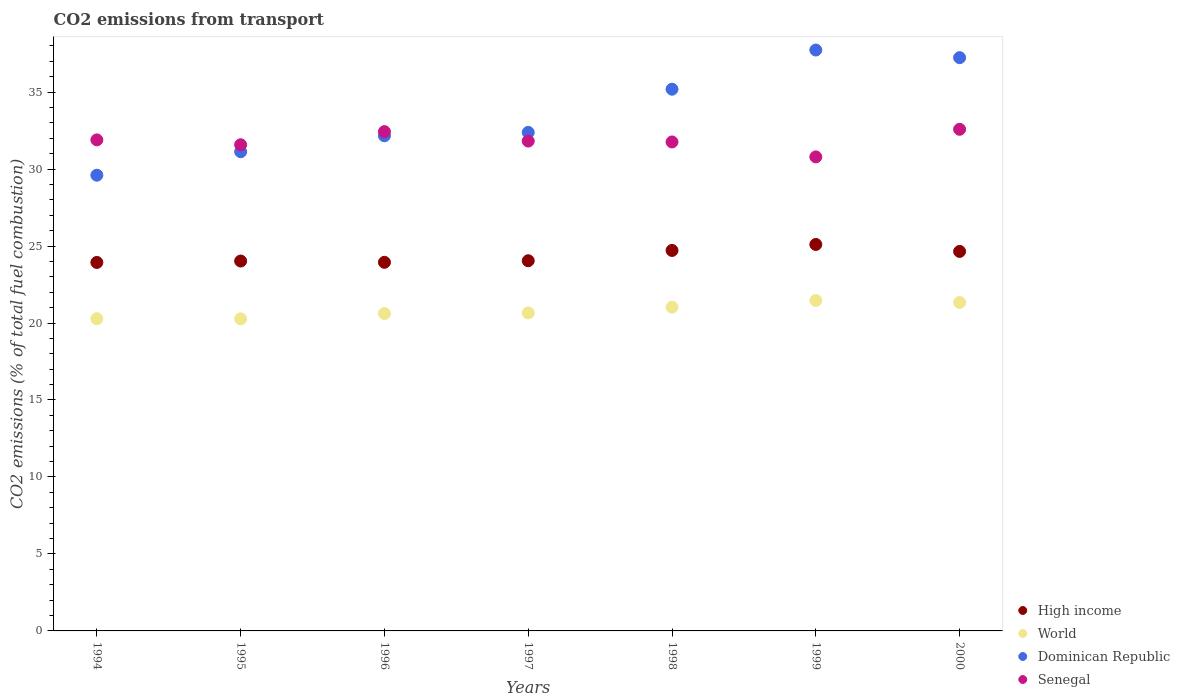How many different coloured dotlines are there?
Keep it short and to the point. 4. What is the total CO2 emitted in Senegal in 1995?
Your response must be concise. 31.58. Across all years, what is the maximum total CO2 emitted in Senegal?
Make the answer very short. 32.58. Across all years, what is the minimum total CO2 emitted in World?
Offer a very short reply. 20.27. In which year was the total CO2 emitted in High income maximum?
Ensure brevity in your answer.  1999. What is the total total CO2 emitted in High income in the graph?
Offer a very short reply. 170.42. What is the difference between the total CO2 emitted in World in 1997 and that in 1998?
Your answer should be very brief. -0.37. What is the difference between the total CO2 emitted in World in 1999 and the total CO2 emitted in High income in 2000?
Ensure brevity in your answer.  -3.19. What is the average total CO2 emitted in Dominican Republic per year?
Provide a succinct answer. 33.63. In the year 1998, what is the difference between the total CO2 emitted in Senegal and total CO2 emitted in World?
Your answer should be compact. 10.73. In how many years, is the total CO2 emitted in World greater than 17?
Offer a terse response. 7. What is the ratio of the total CO2 emitted in Dominican Republic in 1995 to that in 2000?
Your response must be concise. 0.84. Is the total CO2 emitted in Dominican Republic in 1994 less than that in 1995?
Your answer should be very brief. Yes. Is the difference between the total CO2 emitted in Senegal in 1995 and 1998 greater than the difference between the total CO2 emitted in World in 1995 and 1998?
Provide a succinct answer. Yes. What is the difference between the highest and the second highest total CO2 emitted in Dominican Republic?
Your answer should be very brief. 0.5. What is the difference between the highest and the lowest total CO2 emitted in World?
Provide a succinct answer. 1.19. In how many years, is the total CO2 emitted in High income greater than the average total CO2 emitted in High income taken over all years?
Ensure brevity in your answer.  3. Is the sum of the total CO2 emitted in Dominican Republic in 1996 and 1999 greater than the maximum total CO2 emitted in Senegal across all years?
Offer a terse response. Yes. Is it the case that in every year, the sum of the total CO2 emitted in Senegal and total CO2 emitted in High income  is greater than the sum of total CO2 emitted in World and total CO2 emitted in Dominican Republic?
Give a very brief answer. Yes. Does the total CO2 emitted in World monotonically increase over the years?
Give a very brief answer. No. Is the total CO2 emitted in High income strictly less than the total CO2 emitted in World over the years?
Offer a very short reply. No. How many dotlines are there?
Your answer should be compact. 4. How many years are there in the graph?
Your response must be concise. 7. Are the values on the major ticks of Y-axis written in scientific E-notation?
Offer a terse response. No. Does the graph contain any zero values?
Offer a terse response. No. Does the graph contain grids?
Your answer should be compact. No. What is the title of the graph?
Provide a short and direct response. CO2 emissions from transport. What is the label or title of the Y-axis?
Give a very brief answer. CO2 emissions (% of total fuel combustion). What is the CO2 emissions (% of total fuel combustion) of High income in 1994?
Give a very brief answer. 23.93. What is the CO2 emissions (% of total fuel combustion) of World in 1994?
Your answer should be very brief. 20.28. What is the CO2 emissions (% of total fuel combustion) of Dominican Republic in 1994?
Offer a very short reply. 29.6. What is the CO2 emissions (% of total fuel combustion) in Senegal in 1994?
Provide a short and direct response. 31.9. What is the CO2 emissions (% of total fuel combustion) of High income in 1995?
Ensure brevity in your answer.  24.03. What is the CO2 emissions (% of total fuel combustion) of World in 1995?
Keep it short and to the point. 20.27. What is the CO2 emissions (% of total fuel combustion) in Dominican Republic in 1995?
Your response must be concise. 31.13. What is the CO2 emissions (% of total fuel combustion) of Senegal in 1995?
Give a very brief answer. 31.58. What is the CO2 emissions (% of total fuel combustion) in High income in 1996?
Keep it short and to the point. 23.94. What is the CO2 emissions (% of total fuel combustion) of World in 1996?
Your answer should be very brief. 20.61. What is the CO2 emissions (% of total fuel combustion) of Dominican Republic in 1996?
Ensure brevity in your answer.  32.16. What is the CO2 emissions (% of total fuel combustion) of Senegal in 1996?
Your answer should be compact. 32.43. What is the CO2 emissions (% of total fuel combustion) in High income in 1997?
Provide a succinct answer. 24.05. What is the CO2 emissions (% of total fuel combustion) of World in 1997?
Give a very brief answer. 20.66. What is the CO2 emissions (% of total fuel combustion) in Dominican Republic in 1997?
Ensure brevity in your answer.  32.38. What is the CO2 emissions (% of total fuel combustion) in Senegal in 1997?
Give a very brief answer. 31.82. What is the CO2 emissions (% of total fuel combustion) in High income in 1998?
Provide a short and direct response. 24.71. What is the CO2 emissions (% of total fuel combustion) in World in 1998?
Keep it short and to the point. 21.03. What is the CO2 emissions (% of total fuel combustion) of Dominican Republic in 1998?
Keep it short and to the point. 35.19. What is the CO2 emissions (% of total fuel combustion) of Senegal in 1998?
Ensure brevity in your answer.  31.76. What is the CO2 emissions (% of total fuel combustion) of High income in 1999?
Keep it short and to the point. 25.1. What is the CO2 emissions (% of total fuel combustion) in World in 1999?
Ensure brevity in your answer.  21.46. What is the CO2 emissions (% of total fuel combustion) in Dominican Republic in 1999?
Give a very brief answer. 37.73. What is the CO2 emissions (% of total fuel combustion) of Senegal in 1999?
Ensure brevity in your answer.  30.79. What is the CO2 emissions (% of total fuel combustion) of High income in 2000?
Offer a terse response. 24.65. What is the CO2 emissions (% of total fuel combustion) in World in 2000?
Offer a terse response. 21.34. What is the CO2 emissions (% of total fuel combustion) in Dominican Republic in 2000?
Keep it short and to the point. 37.24. What is the CO2 emissions (% of total fuel combustion) of Senegal in 2000?
Your answer should be very brief. 32.58. Across all years, what is the maximum CO2 emissions (% of total fuel combustion) of High income?
Keep it short and to the point. 25.1. Across all years, what is the maximum CO2 emissions (% of total fuel combustion) of World?
Your response must be concise. 21.46. Across all years, what is the maximum CO2 emissions (% of total fuel combustion) in Dominican Republic?
Your response must be concise. 37.73. Across all years, what is the maximum CO2 emissions (% of total fuel combustion) of Senegal?
Ensure brevity in your answer.  32.58. Across all years, what is the minimum CO2 emissions (% of total fuel combustion) in High income?
Offer a terse response. 23.93. Across all years, what is the minimum CO2 emissions (% of total fuel combustion) of World?
Your answer should be compact. 20.27. Across all years, what is the minimum CO2 emissions (% of total fuel combustion) in Dominican Republic?
Keep it short and to the point. 29.6. Across all years, what is the minimum CO2 emissions (% of total fuel combustion) in Senegal?
Give a very brief answer. 30.79. What is the total CO2 emissions (% of total fuel combustion) in High income in the graph?
Provide a succinct answer. 170.42. What is the total CO2 emissions (% of total fuel combustion) in World in the graph?
Your answer should be very brief. 145.65. What is the total CO2 emissions (% of total fuel combustion) of Dominican Republic in the graph?
Provide a short and direct response. 235.43. What is the total CO2 emissions (% of total fuel combustion) in Senegal in the graph?
Provide a succinct answer. 222.86. What is the difference between the CO2 emissions (% of total fuel combustion) in High income in 1994 and that in 1995?
Your response must be concise. -0.09. What is the difference between the CO2 emissions (% of total fuel combustion) in World in 1994 and that in 1995?
Your response must be concise. 0.01. What is the difference between the CO2 emissions (% of total fuel combustion) of Dominican Republic in 1994 and that in 1995?
Offer a terse response. -1.53. What is the difference between the CO2 emissions (% of total fuel combustion) in Senegal in 1994 and that in 1995?
Your answer should be very brief. 0.32. What is the difference between the CO2 emissions (% of total fuel combustion) in High income in 1994 and that in 1996?
Give a very brief answer. -0.01. What is the difference between the CO2 emissions (% of total fuel combustion) in World in 1994 and that in 1996?
Your response must be concise. -0.34. What is the difference between the CO2 emissions (% of total fuel combustion) of Dominican Republic in 1994 and that in 1996?
Make the answer very short. -2.56. What is the difference between the CO2 emissions (% of total fuel combustion) in Senegal in 1994 and that in 1996?
Your answer should be compact. -0.54. What is the difference between the CO2 emissions (% of total fuel combustion) in High income in 1994 and that in 1997?
Your answer should be very brief. -0.11. What is the difference between the CO2 emissions (% of total fuel combustion) in World in 1994 and that in 1997?
Your answer should be compact. -0.38. What is the difference between the CO2 emissions (% of total fuel combustion) of Dominican Republic in 1994 and that in 1997?
Keep it short and to the point. -2.78. What is the difference between the CO2 emissions (% of total fuel combustion) in Senegal in 1994 and that in 1997?
Provide a short and direct response. 0.08. What is the difference between the CO2 emissions (% of total fuel combustion) of High income in 1994 and that in 1998?
Keep it short and to the point. -0.78. What is the difference between the CO2 emissions (% of total fuel combustion) of World in 1994 and that in 1998?
Give a very brief answer. -0.75. What is the difference between the CO2 emissions (% of total fuel combustion) of Dominican Republic in 1994 and that in 1998?
Make the answer very short. -5.59. What is the difference between the CO2 emissions (% of total fuel combustion) of Senegal in 1994 and that in 1998?
Offer a terse response. 0.14. What is the difference between the CO2 emissions (% of total fuel combustion) in High income in 1994 and that in 1999?
Provide a short and direct response. -1.17. What is the difference between the CO2 emissions (% of total fuel combustion) in World in 1994 and that in 1999?
Your response must be concise. -1.18. What is the difference between the CO2 emissions (% of total fuel combustion) in Dominican Republic in 1994 and that in 1999?
Your response must be concise. -8.13. What is the difference between the CO2 emissions (% of total fuel combustion) in Senegal in 1994 and that in 1999?
Your answer should be very brief. 1.11. What is the difference between the CO2 emissions (% of total fuel combustion) of High income in 1994 and that in 2000?
Provide a succinct answer. -0.72. What is the difference between the CO2 emissions (% of total fuel combustion) of World in 1994 and that in 2000?
Provide a succinct answer. -1.06. What is the difference between the CO2 emissions (% of total fuel combustion) in Dominican Republic in 1994 and that in 2000?
Your answer should be very brief. -7.64. What is the difference between the CO2 emissions (% of total fuel combustion) in Senegal in 1994 and that in 2000?
Your answer should be very brief. -0.69. What is the difference between the CO2 emissions (% of total fuel combustion) in High income in 1995 and that in 1996?
Your response must be concise. 0.08. What is the difference between the CO2 emissions (% of total fuel combustion) in World in 1995 and that in 1996?
Your answer should be compact. -0.34. What is the difference between the CO2 emissions (% of total fuel combustion) of Dominican Republic in 1995 and that in 1996?
Give a very brief answer. -1.04. What is the difference between the CO2 emissions (% of total fuel combustion) in Senegal in 1995 and that in 1996?
Provide a short and direct response. -0.85. What is the difference between the CO2 emissions (% of total fuel combustion) of High income in 1995 and that in 1997?
Your response must be concise. -0.02. What is the difference between the CO2 emissions (% of total fuel combustion) of World in 1995 and that in 1997?
Your answer should be compact. -0.39. What is the difference between the CO2 emissions (% of total fuel combustion) in Dominican Republic in 1995 and that in 1997?
Provide a succinct answer. -1.25. What is the difference between the CO2 emissions (% of total fuel combustion) in Senegal in 1995 and that in 1997?
Offer a very short reply. -0.24. What is the difference between the CO2 emissions (% of total fuel combustion) in High income in 1995 and that in 1998?
Make the answer very short. -0.69. What is the difference between the CO2 emissions (% of total fuel combustion) of World in 1995 and that in 1998?
Give a very brief answer. -0.76. What is the difference between the CO2 emissions (% of total fuel combustion) of Dominican Republic in 1995 and that in 1998?
Make the answer very short. -4.06. What is the difference between the CO2 emissions (% of total fuel combustion) in Senegal in 1995 and that in 1998?
Offer a very short reply. -0.18. What is the difference between the CO2 emissions (% of total fuel combustion) in High income in 1995 and that in 1999?
Give a very brief answer. -1.08. What is the difference between the CO2 emissions (% of total fuel combustion) of World in 1995 and that in 1999?
Your response must be concise. -1.19. What is the difference between the CO2 emissions (% of total fuel combustion) in Dominican Republic in 1995 and that in 1999?
Ensure brevity in your answer.  -6.61. What is the difference between the CO2 emissions (% of total fuel combustion) of Senegal in 1995 and that in 1999?
Keep it short and to the point. 0.79. What is the difference between the CO2 emissions (% of total fuel combustion) in High income in 1995 and that in 2000?
Ensure brevity in your answer.  -0.62. What is the difference between the CO2 emissions (% of total fuel combustion) of World in 1995 and that in 2000?
Keep it short and to the point. -1.07. What is the difference between the CO2 emissions (% of total fuel combustion) in Dominican Republic in 1995 and that in 2000?
Keep it short and to the point. -6.11. What is the difference between the CO2 emissions (% of total fuel combustion) of Senegal in 1995 and that in 2000?
Keep it short and to the point. -1.01. What is the difference between the CO2 emissions (% of total fuel combustion) of High income in 1996 and that in 1997?
Ensure brevity in your answer.  -0.1. What is the difference between the CO2 emissions (% of total fuel combustion) in World in 1996 and that in 1997?
Give a very brief answer. -0.04. What is the difference between the CO2 emissions (% of total fuel combustion) of Dominican Republic in 1996 and that in 1997?
Provide a succinct answer. -0.22. What is the difference between the CO2 emissions (% of total fuel combustion) in Senegal in 1996 and that in 1997?
Provide a short and direct response. 0.61. What is the difference between the CO2 emissions (% of total fuel combustion) of High income in 1996 and that in 1998?
Provide a short and direct response. -0.77. What is the difference between the CO2 emissions (% of total fuel combustion) in World in 1996 and that in 1998?
Make the answer very short. -0.41. What is the difference between the CO2 emissions (% of total fuel combustion) of Dominican Republic in 1996 and that in 1998?
Make the answer very short. -3.02. What is the difference between the CO2 emissions (% of total fuel combustion) of Senegal in 1996 and that in 1998?
Keep it short and to the point. 0.67. What is the difference between the CO2 emissions (% of total fuel combustion) of High income in 1996 and that in 1999?
Offer a terse response. -1.16. What is the difference between the CO2 emissions (% of total fuel combustion) in World in 1996 and that in 1999?
Give a very brief answer. -0.85. What is the difference between the CO2 emissions (% of total fuel combustion) of Dominican Republic in 1996 and that in 1999?
Give a very brief answer. -5.57. What is the difference between the CO2 emissions (% of total fuel combustion) of Senegal in 1996 and that in 1999?
Give a very brief answer. 1.64. What is the difference between the CO2 emissions (% of total fuel combustion) of High income in 1996 and that in 2000?
Offer a very short reply. -0.71. What is the difference between the CO2 emissions (% of total fuel combustion) in World in 1996 and that in 2000?
Ensure brevity in your answer.  -0.72. What is the difference between the CO2 emissions (% of total fuel combustion) of Dominican Republic in 1996 and that in 2000?
Make the answer very short. -5.07. What is the difference between the CO2 emissions (% of total fuel combustion) in Senegal in 1996 and that in 2000?
Give a very brief answer. -0.15. What is the difference between the CO2 emissions (% of total fuel combustion) of High income in 1997 and that in 1998?
Your answer should be very brief. -0.67. What is the difference between the CO2 emissions (% of total fuel combustion) of World in 1997 and that in 1998?
Give a very brief answer. -0.37. What is the difference between the CO2 emissions (% of total fuel combustion) of Dominican Republic in 1997 and that in 1998?
Make the answer very short. -2.81. What is the difference between the CO2 emissions (% of total fuel combustion) of Senegal in 1997 and that in 1998?
Give a very brief answer. 0.06. What is the difference between the CO2 emissions (% of total fuel combustion) in High income in 1997 and that in 1999?
Your answer should be very brief. -1.06. What is the difference between the CO2 emissions (% of total fuel combustion) of World in 1997 and that in 1999?
Give a very brief answer. -0.81. What is the difference between the CO2 emissions (% of total fuel combustion) of Dominican Republic in 1997 and that in 1999?
Your response must be concise. -5.35. What is the difference between the CO2 emissions (% of total fuel combustion) in Senegal in 1997 and that in 1999?
Make the answer very short. 1.03. What is the difference between the CO2 emissions (% of total fuel combustion) of High income in 1997 and that in 2000?
Keep it short and to the point. -0.6. What is the difference between the CO2 emissions (% of total fuel combustion) in World in 1997 and that in 2000?
Ensure brevity in your answer.  -0.68. What is the difference between the CO2 emissions (% of total fuel combustion) in Dominican Republic in 1997 and that in 2000?
Your answer should be very brief. -4.86. What is the difference between the CO2 emissions (% of total fuel combustion) in Senegal in 1997 and that in 2000?
Ensure brevity in your answer.  -0.77. What is the difference between the CO2 emissions (% of total fuel combustion) in High income in 1998 and that in 1999?
Make the answer very short. -0.39. What is the difference between the CO2 emissions (% of total fuel combustion) in World in 1998 and that in 1999?
Your answer should be very brief. -0.43. What is the difference between the CO2 emissions (% of total fuel combustion) of Dominican Republic in 1998 and that in 1999?
Your answer should be compact. -2.55. What is the difference between the CO2 emissions (% of total fuel combustion) in High income in 1998 and that in 2000?
Your response must be concise. 0.06. What is the difference between the CO2 emissions (% of total fuel combustion) of World in 1998 and that in 2000?
Keep it short and to the point. -0.31. What is the difference between the CO2 emissions (% of total fuel combustion) of Dominican Republic in 1998 and that in 2000?
Give a very brief answer. -2.05. What is the difference between the CO2 emissions (% of total fuel combustion) in Senegal in 1998 and that in 2000?
Provide a short and direct response. -0.82. What is the difference between the CO2 emissions (% of total fuel combustion) of High income in 1999 and that in 2000?
Your response must be concise. 0.45. What is the difference between the CO2 emissions (% of total fuel combustion) of World in 1999 and that in 2000?
Keep it short and to the point. 0.13. What is the difference between the CO2 emissions (% of total fuel combustion) of Dominican Republic in 1999 and that in 2000?
Offer a terse response. 0.5. What is the difference between the CO2 emissions (% of total fuel combustion) of Senegal in 1999 and that in 2000?
Offer a terse response. -1.79. What is the difference between the CO2 emissions (% of total fuel combustion) of High income in 1994 and the CO2 emissions (% of total fuel combustion) of World in 1995?
Provide a short and direct response. 3.66. What is the difference between the CO2 emissions (% of total fuel combustion) in High income in 1994 and the CO2 emissions (% of total fuel combustion) in Dominican Republic in 1995?
Your answer should be very brief. -7.19. What is the difference between the CO2 emissions (% of total fuel combustion) of High income in 1994 and the CO2 emissions (% of total fuel combustion) of Senegal in 1995?
Provide a succinct answer. -7.64. What is the difference between the CO2 emissions (% of total fuel combustion) of World in 1994 and the CO2 emissions (% of total fuel combustion) of Dominican Republic in 1995?
Your answer should be very brief. -10.85. What is the difference between the CO2 emissions (% of total fuel combustion) of World in 1994 and the CO2 emissions (% of total fuel combustion) of Senegal in 1995?
Your answer should be compact. -11.3. What is the difference between the CO2 emissions (% of total fuel combustion) in Dominican Republic in 1994 and the CO2 emissions (% of total fuel combustion) in Senegal in 1995?
Offer a terse response. -1.98. What is the difference between the CO2 emissions (% of total fuel combustion) in High income in 1994 and the CO2 emissions (% of total fuel combustion) in World in 1996?
Ensure brevity in your answer.  3.32. What is the difference between the CO2 emissions (% of total fuel combustion) in High income in 1994 and the CO2 emissions (% of total fuel combustion) in Dominican Republic in 1996?
Give a very brief answer. -8.23. What is the difference between the CO2 emissions (% of total fuel combustion) in High income in 1994 and the CO2 emissions (% of total fuel combustion) in Senegal in 1996?
Provide a succinct answer. -8.5. What is the difference between the CO2 emissions (% of total fuel combustion) in World in 1994 and the CO2 emissions (% of total fuel combustion) in Dominican Republic in 1996?
Ensure brevity in your answer.  -11.89. What is the difference between the CO2 emissions (% of total fuel combustion) of World in 1994 and the CO2 emissions (% of total fuel combustion) of Senegal in 1996?
Your answer should be compact. -12.15. What is the difference between the CO2 emissions (% of total fuel combustion) of Dominican Republic in 1994 and the CO2 emissions (% of total fuel combustion) of Senegal in 1996?
Offer a very short reply. -2.83. What is the difference between the CO2 emissions (% of total fuel combustion) in High income in 1994 and the CO2 emissions (% of total fuel combustion) in World in 1997?
Your response must be concise. 3.28. What is the difference between the CO2 emissions (% of total fuel combustion) in High income in 1994 and the CO2 emissions (% of total fuel combustion) in Dominican Republic in 1997?
Provide a succinct answer. -8.45. What is the difference between the CO2 emissions (% of total fuel combustion) of High income in 1994 and the CO2 emissions (% of total fuel combustion) of Senegal in 1997?
Keep it short and to the point. -7.88. What is the difference between the CO2 emissions (% of total fuel combustion) in World in 1994 and the CO2 emissions (% of total fuel combustion) in Dominican Republic in 1997?
Offer a very short reply. -12.1. What is the difference between the CO2 emissions (% of total fuel combustion) of World in 1994 and the CO2 emissions (% of total fuel combustion) of Senegal in 1997?
Your answer should be compact. -11.54. What is the difference between the CO2 emissions (% of total fuel combustion) in Dominican Republic in 1994 and the CO2 emissions (% of total fuel combustion) in Senegal in 1997?
Ensure brevity in your answer.  -2.22. What is the difference between the CO2 emissions (% of total fuel combustion) of High income in 1994 and the CO2 emissions (% of total fuel combustion) of World in 1998?
Make the answer very short. 2.91. What is the difference between the CO2 emissions (% of total fuel combustion) in High income in 1994 and the CO2 emissions (% of total fuel combustion) in Dominican Republic in 1998?
Your answer should be very brief. -11.25. What is the difference between the CO2 emissions (% of total fuel combustion) of High income in 1994 and the CO2 emissions (% of total fuel combustion) of Senegal in 1998?
Your answer should be very brief. -7.83. What is the difference between the CO2 emissions (% of total fuel combustion) in World in 1994 and the CO2 emissions (% of total fuel combustion) in Dominican Republic in 1998?
Your answer should be compact. -14.91. What is the difference between the CO2 emissions (% of total fuel combustion) of World in 1994 and the CO2 emissions (% of total fuel combustion) of Senegal in 1998?
Offer a very short reply. -11.48. What is the difference between the CO2 emissions (% of total fuel combustion) in Dominican Republic in 1994 and the CO2 emissions (% of total fuel combustion) in Senegal in 1998?
Give a very brief answer. -2.16. What is the difference between the CO2 emissions (% of total fuel combustion) of High income in 1994 and the CO2 emissions (% of total fuel combustion) of World in 1999?
Your answer should be compact. 2.47. What is the difference between the CO2 emissions (% of total fuel combustion) of High income in 1994 and the CO2 emissions (% of total fuel combustion) of Dominican Republic in 1999?
Provide a succinct answer. -13.8. What is the difference between the CO2 emissions (% of total fuel combustion) in High income in 1994 and the CO2 emissions (% of total fuel combustion) in Senegal in 1999?
Give a very brief answer. -6.86. What is the difference between the CO2 emissions (% of total fuel combustion) in World in 1994 and the CO2 emissions (% of total fuel combustion) in Dominican Republic in 1999?
Provide a succinct answer. -17.45. What is the difference between the CO2 emissions (% of total fuel combustion) of World in 1994 and the CO2 emissions (% of total fuel combustion) of Senegal in 1999?
Ensure brevity in your answer.  -10.51. What is the difference between the CO2 emissions (% of total fuel combustion) in Dominican Republic in 1994 and the CO2 emissions (% of total fuel combustion) in Senegal in 1999?
Provide a succinct answer. -1.19. What is the difference between the CO2 emissions (% of total fuel combustion) of High income in 1994 and the CO2 emissions (% of total fuel combustion) of World in 2000?
Give a very brief answer. 2.6. What is the difference between the CO2 emissions (% of total fuel combustion) in High income in 1994 and the CO2 emissions (% of total fuel combustion) in Dominican Republic in 2000?
Provide a succinct answer. -13.3. What is the difference between the CO2 emissions (% of total fuel combustion) of High income in 1994 and the CO2 emissions (% of total fuel combustion) of Senegal in 2000?
Your answer should be compact. -8.65. What is the difference between the CO2 emissions (% of total fuel combustion) of World in 1994 and the CO2 emissions (% of total fuel combustion) of Dominican Republic in 2000?
Provide a succinct answer. -16.96. What is the difference between the CO2 emissions (% of total fuel combustion) in World in 1994 and the CO2 emissions (% of total fuel combustion) in Senegal in 2000?
Your answer should be very brief. -12.31. What is the difference between the CO2 emissions (% of total fuel combustion) in Dominican Republic in 1994 and the CO2 emissions (% of total fuel combustion) in Senegal in 2000?
Keep it short and to the point. -2.98. What is the difference between the CO2 emissions (% of total fuel combustion) in High income in 1995 and the CO2 emissions (% of total fuel combustion) in World in 1996?
Give a very brief answer. 3.41. What is the difference between the CO2 emissions (% of total fuel combustion) of High income in 1995 and the CO2 emissions (% of total fuel combustion) of Dominican Republic in 1996?
Your answer should be compact. -8.14. What is the difference between the CO2 emissions (% of total fuel combustion) in High income in 1995 and the CO2 emissions (% of total fuel combustion) in Senegal in 1996?
Offer a terse response. -8.41. What is the difference between the CO2 emissions (% of total fuel combustion) in World in 1995 and the CO2 emissions (% of total fuel combustion) in Dominican Republic in 1996?
Your response must be concise. -11.89. What is the difference between the CO2 emissions (% of total fuel combustion) in World in 1995 and the CO2 emissions (% of total fuel combustion) in Senegal in 1996?
Make the answer very short. -12.16. What is the difference between the CO2 emissions (% of total fuel combustion) of Dominican Republic in 1995 and the CO2 emissions (% of total fuel combustion) of Senegal in 1996?
Offer a terse response. -1.31. What is the difference between the CO2 emissions (% of total fuel combustion) of High income in 1995 and the CO2 emissions (% of total fuel combustion) of World in 1997?
Your answer should be very brief. 3.37. What is the difference between the CO2 emissions (% of total fuel combustion) in High income in 1995 and the CO2 emissions (% of total fuel combustion) in Dominican Republic in 1997?
Provide a succinct answer. -8.35. What is the difference between the CO2 emissions (% of total fuel combustion) in High income in 1995 and the CO2 emissions (% of total fuel combustion) in Senegal in 1997?
Your response must be concise. -7.79. What is the difference between the CO2 emissions (% of total fuel combustion) in World in 1995 and the CO2 emissions (% of total fuel combustion) in Dominican Republic in 1997?
Keep it short and to the point. -12.11. What is the difference between the CO2 emissions (% of total fuel combustion) of World in 1995 and the CO2 emissions (% of total fuel combustion) of Senegal in 1997?
Provide a short and direct response. -11.55. What is the difference between the CO2 emissions (% of total fuel combustion) in Dominican Republic in 1995 and the CO2 emissions (% of total fuel combustion) in Senegal in 1997?
Offer a very short reply. -0.69. What is the difference between the CO2 emissions (% of total fuel combustion) in High income in 1995 and the CO2 emissions (% of total fuel combustion) in World in 1998?
Offer a very short reply. 3. What is the difference between the CO2 emissions (% of total fuel combustion) in High income in 1995 and the CO2 emissions (% of total fuel combustion) in Dominican Republic in 1998?
Your answer should be very brief. -11.16. What is the difference between the CO2 emissions (% of total fuel combustion) in High income in 1995 and the CO2 emissions (% of total fuel combustion) in Senegal in 1998?
Offer a very short reply. -7.73. What is the difference between the CO2 emissions (% of total fuel combustion) of World in 1995 and the CO2 emissions (% of total fuel combustion) of Dominican Republic in 1998?
Ensure brevity in your answer.  -14.92. What is the difference between the CO2 emissions (% of total fuel combustion) in World in 1995 and the CO2 emissions (% of total fuel combustion) in Senegal in 1998?
Make the answer very short. -11.49. What is the difference between the CO2 emissions (% of total fuel combustion) in Dominican Republic in 1995 and the CO2 emissions (% of total fuel combustion) in Senegal in 1998?
Make the answer very short. -0.63. What is the difference between the CO2 emissions (% of total fuel combustion) in High income in 1995 and the CO2 emissions (% of total fuel combustion) in World in 1999?
Make the answer very short. 2.56. What is the difference between the CO2 emissions (% of total fuel combustion) of High income in 1995 and the CO2 emissions (% of total fuel combustion) of Dominican Republic in 1999?
Your answer should be very brief. -13.71. What is the difference between the CO2 emissions (% of total fuel combustion) in High income in 1995 and the CO2 emissions (% of total fuel combustion) in Senegal in 1999?
Provide a succinct answer. -6.76. What is the difference between the CO2 emissions (% of total fuel combustion) in World in 1995 and the CO2 emissions (% of total fuel combustion) in Dominican Republic in 1999?
Give a very brief answer. -17.46. What is the difference between the CO2 emissions (% of total fuel combustion) in World in 1995 and the CO2 emissions (% of total fuel combustion) in Senegal in 1999?
Your answer should be very brief. -10.52. What is the difference between the CO2 emissions (% of total fuel combustion) of Dominican Republic in 1995 and the CO2 emissions (% of total fuel combustion) of Senegal in 1999?
Your answer should be very brief. 0.34. What is the difference between the CO2 emissions (% of total fuel combustion) in High income in 1995 and the CO2 emissions (% of total fuel combustion) in World in 2000?
Provide a short and direct response. 2.69. What is the difference between the CO2 emissions (% of total fuel combustion) of High income in 1995 and the CO2 emissions (% of total fuel combustion) of Dominican Republic in 2000?
Your response must be concise. -13.21. What is the difference between the CO2 emissions (% of total fuel combustion) in High income in 1995 and the CO2 emissions (% of total fuel combustion) in Senegal in 2000?
Provide a short and direct response. -8.56. What is the difference between the CO2 emissions (% of total fuel combustion) in World in 1995 and the CO2 emissions (% of total fuel combustion) in Dominican Republic in 2000?
Give a very brief answer. -16.96. What is the difference between the CO2 emissions (% of total fuel combustion) of World in 1995 and the CO2 emissions (% of total fuel combustion) of Senegal in 2000?
Provide a succinct answer. -12.31. What is the difference between the CO2 emissions (% of total fuel combustion) of Dominican Republic in 1995 and the CO2 emissions (% of total fuel combustion) of Senegal in 2000?
Your answer should be very brief. -1.46. What is the difference between the CO2 emissions (% of total fuel combustion) of High income in 1996 and the CO2 emissions (% of total fuel combustion) of World in 1997?
Offer a very short reply. 3.29. What is the difference between the CO2 emissions (% of total fuel combustion) in High income in 1996 and the CO2 emissions (% of total fuel combustion) in Dominican Republic in 1997?
Provide a succinct answer. -8.44. What is the difference between the CO2 emissions (% of total fuel combustion) in High income in 1996 and the CO2 emissions (% of total fuel combustion) in Senegal in 1997?
Your answer should be very brief. -7.88. What is the difference between the CO2 emissions (% of total fuel combustion) of World in 1996 and the CO2 emissions (% of total fuel combustion) of Dominican Republic in 1997?
Offer a terse response. -11.77. What is the difference between the CO2 emissions (% of total fuel combustion) in World in 1996 and the CO2 emissions (% of total fuel combustion) in Senegal in 1997?
Your response must be concise. -11.2. What is the difference between the CO2 emissions (% of total fuel combustion) in Dominican Republic in 1996 and the CO2 emissions (% of total fuel combustion) in Senegal in 1997?
Offer a very short reply. 0.35. What is the difference between the CO2 emissions (% of total fuel combustion) in High income in 1996 and the CO2 emissions (% of total fuel combustion) in World in 1998?
Make the answer very short. 2.92. What is the difference between the CO2 emissions (% of total fuel combustion) in High income in 1996 and the CO2 emissions (% of total fuel combustion) in Dominican Republic in 1998?
Ensure brevity in your answer.  -11.24. What is the difference between the CO2 emissions (% of total fuel combustion) of High income in 1996 and the CO2 emissions (% of total fuel combustion) of Senegal in 1998?
Provide a succinct answer. -7.82. What is the difference between the CO2 emissions (% of total fuel combustion) in World in 1996 and the CO2 emissions (% of total fuel combustion) in Dominican Republic in 1998?
Provide a short and direct response. -14.57. What is the difference between the CO2 emissions (% of total fuel combustion) in World in 1996 and the CO2 emissions (% of total fuel combustion) in Senegal in 1998?
Give a very brief answer. -11.15. What is the difference between the CO2 emissions (% of total fuel combustion) of Dominican Republic in 1996 and the CO2 emissions (% of total fuel combustion) of Senegal in 1998?
Ensure brevity in your answer.  0.4. What is the difference between the CO2 emissions (% of total fuel combustion) in High income in 1996 and the CO2 emissions (% of total fuel combustion) in World in 1999?
Give a very brief answer. 2.48. What is the difference between the CO2 emissions (% of total fuel combustion) in High income in 1996 and the CO2 emissions (% of total fuel combustion) in Dominican Republic in 1999?
Offer a very short reply. -13.79. What is the difference between the CO2 emissions (% of total fuel combustion) of High income in 1996 and the CO2 emissions (% of total fuel combustion) of Senegal in 1999?
Your response must be concise. -6.85. What is the difference between the CO2 emissions (% of total fuel combustion) of World in 1996 and the CO2 emissions (% of total fuel combustion) of Dominican Republic in 1999?
Provide a short and direct response. -17.12. What is the difference between the CO2 emissions (% of total fuel combustion) in World in 1996 and the CO2 emissions (% of total fuel combustion) in Senegal in 1999?
Make the answer very short. -10.18. What is the difference between the CO2 emissions (% of total fuel combustion) in Dominican Republic in 1996 and the CO2 emissions (% of total fuel combustion) in Senegal in 1999?
Give a very brief answer. 1.37. What is the difference between the CO2 emissions (% of total fuel combustion) of High income in 1996 and the CO2 emissions (% of total fuel combustion) of World in 2000?
Your answer should be very brief. 2.61. What is the difference between the CO2 emissions (% of total fuel combustion) in High income in 1996 and the CO2 emissions (% of total fuel combustion) in Dominican Republic in 2000?
Provide a succinct answer. -13.29. What is the difference between the CO2 emissions (% of total fuel combustion) in High income in 1996 and the CO2 emissions (% of total fuel combustion) in Senegal in 2000?
Ensure brevity in your answer.  -8.64. What is the difference between the CO2 emissions (% of total fuel combustion) in World in 1996 and the CO2 emissions (% of total fuel combustion) in Dominican Republic in 2000?
Keep it short and to the point. -16.62. What is the difference between the CO2 emissions (% of total fuel combustion) in World in 1996 and the CO2 emissions (% of total fuel combustion) in Senegal in 2000?
Provide a succinct answer. -11.97. What is the difference between the CO2 emissions (% of total fuel combustion) of Dominican Republic in 1996 and the CO2 emissions (% of total fuel combustion) of Senegal in 2000?
Provide a short and direct response. -0.42. What is the difference between the CO2 emissions (% of total fuel combustion) of High income in 1997 and the CO2 emissions (% of total fuel combustion) of World in 1998?
Offer a very short reply. 3.02. What is the difference between the CO2 emissions (% of total fuel combustion) of High income in 1997 and the CO2 emissions (% of total fuel combustion) of Dominican Republic in 1998?
Provide a succinct answer. -11.14. What is the difference between the CO2 emissions (% of total fuel combustion) in High income in 1997 and the CO2 emissions (% of total fuel combustion) in Senegal in 1998?
Keep it short and to the point. -7.72. What is the difference between the CO2 emissions (% of total fuel combustion) of World in 1997 and the CO2 emissions (% of total fuel combustion) of Dominican Republic in 1998?
Your response must be concise. -14.53. What is the difference between the CO2 emissions (% of total fuel combustion) in World in 1997 and the CO2 emissions (% of total fuel combustion) in Senegal in 1998?
Make the answer very short. -11.1. What is the difference between the CO2 emissions (% of total fuel combustion) in Dominican Republic in 1997 and the CO2 emissions (% of total fuel combustion) in Senegal in 1998?
Ensure brevity in your answer.  0.62. What is the difference between the CO2 emissions (% of total fuel combustion) in High income in 1997 and the CO2 emissions (% of total fuel combustion) in World in 1999?
Offer a terse response. 2.58. What is the difference between the CO2 emissions (% of total fuel combustion) of High income in 1997 and the CO2 emissions (% of total fuel combustion) of Dominican Republic in 1999?
Your answer should be very brief. -13.69. What is the difference between the CO2 emissions (% of total fuel combustion) in High income in 1997 and the CO2 emissions (% of total fuel combustion) in Senegal in 1999?
Give a very brief answer. -6.75. What is the difference between the CO2 emissions (% of total fuel combustion) of World in 1997 and the CO2 emissions (% of total fuel combustion) of Dominican Republic in 1999?
Your answer should be very brief. -17.08. What is the difference between the CO2 emissions (% of total fuel combustion) of World in 1997 and the CO2 emissions (% of total fuel combustion) of Senegal in 1999?
Offer a terse response. -10.13. What is the difference between the CO2 emissions (% of total fuel combustion) of Dominican Republic in 1997 and the CO2 emissions (% of total fuel combustion) of Senegal in 1999?
Offer a terse response. 1.59. What is the difference between the CO2 emissions (% of total fuel combustion) of High income in 1997 and the CO2 emissions (% of total fuel combustion) of World in 2000?
Give a very brief answer. 2.71. What is the difference between the CO2 emissions (% of total fuel combustion) in High income in 1997 and the CO2 emissions (% of total fuel combustion) in Dominican Republic in 2000?
Ensure brevity in your answer.  -13.19. What is the difference between the CO2 emissions (% of total fuel combustion) of High income in 1997 and the CO2 emissions (% of total fuel combustion) of Senegal in 2000?
Give a very brief answer. -8.54. What is the difference between the CO2 emissions (% of total fuel combustion) in World in 1997 and the CO2 emissions (% of total fuel combustion) in Dominican Republic in 2000?
Ensure brevity in your answer.  -16.58. What is the difference between the CO2 emissions (% of total fuel combustion) of World in 1997 and the CO2 emissions (% of total fuel combustion) of Senegal in 2000?
Offer a terse response. -11.93. What is the difference between the CO2 emissions (% of total fuel combustion) in Dominican Republic in 1997 and the CO2 emissions (% of total fuel combustion) in Senegal in 2000?
Ensure brevity in your answer.  -0.2. What is the difference between the CO2 emissions (% of total fuel combustion) of High income in 1998 and the CO2 emissions (% of total fuel combustion) of World in 1999?
Provide a short and direct response. 3.25. What is the difference between the CO2 emissions (% of total fuel combustion) of High income in 1998 and the CO2 emissions (% of total fuel combustion) of Dominican Republic in 1999?
Your answer should be very brief. -13.02. What is the difference between the CO2 emissions (% of total fuel combustion) of High income in 1998 and the CO2 emissions (% of total fuel combustion) of Senegal in 1999?
Make the answer very short. -6.08. What is the difference between the CO2 emissions (% of total fuel combustion) in World in 1998 and the CO2 emissions (% of total fuel combustion) in Dominican Republic in 1999?
Your response must be concise. -16.71. What is the difference between the CO2 emissions (% of total fuel combustion) of World in 1998 and the CO2 emissions (% of total fuel combustion) of Senegal in 1999?
Your answer should be very brief. -9.76. What is the difference between the CO2 emissions (% of total fuel combustion) of Dominican Republic in 1998 and the CO2 emissions (% of total fuel combustion) of Senegal in 1999?
Make the answer very short. 4.4. What is the difference between the CO2 emissions (% of total fuel combustion) in High income in 1998 and the CO2 emissions (% of total fuel combustion) in World in 2000?
Offer a very short reply. 3.38. What is the difference between the CO2 emissions (% of total fuel combustion) of High income in 1998 and the CO2 emissions (% of total fuel combustion) of Dominican Republic in 2000?
Make the answer very short. -12.52. What is the difference between the CO2 emissions (% of total fuel combustion) of High income in 1998 and the CO2 emissions (% of total fuel combustion) of Senegal in 2000?
Make the answer very short. -7.87. What is the difference between the CO2 emissions (% of total fuel combustion) in World in 1998 and the CO2 emissions (% of total fuel combustion) in Dominican Republic in 2000?
Provide a succinct answer. -16.21. What is the difference between the CO2 emissions (% of total fuel combustion) in World in 1998 and the CO2 emissions (% of total fuel combustion) in Senegal in 2000?
Your response must be concise. -11.56. What is the difference between the CO2 emissions (% of total fuel combustion) of Dominican Republic in 1998 and the CO2 emissions (% of total fuel combustion) of Senegal in 2000?
Your answer should be compact. 2.6. What is the difference between the CO2 emissions (% of total fuel combustion) of High income in 1999 and the CO2 emissions (% of total fuel combustion) of World in 2000?
Your answer should be very brief. 3.77. What is the difference between the CO2 emissions (% of total fuel combustion) of High income in 1999 and the CO2 emissions (% of total fuel combustion) of Dominican Republic in 2000?
Keep it short and to the point. -12.13. What is the difference between the CO2 emissions (% of total fuel combustion) of High income in 1999 and the CO2 emissions (% of total fuel combustion) of Senegal in 2000?
Give a very brief answer. -7.48. What is the difference between the CO2 emissions (% of total fuel combustion) in World in 1999 and the CO2 emissions (% of total fuel combustion) in Dominican Republic in 2000?
Your answer should be very brief. -15.77. What is the difference between the CO2 emissions (% of total fuel combustion) of World in 1999 and the CO2 emissions (% of total fuel combustion) of Senegal in 2000?
Provide a short and direct response. -11.12. What is the difference between the CO2 emissions (% of total fuel combustion) in Dominican Republic in 1999 and the CO2 emissions (% of total fuel combustion) in Senegal in 2000?
Provide a short and direct response. 5.15. What is the average CO2 emissions (% of total fuel combustion) of High income per year?
Give a very brief answer. 24.35. What is the average CO2 emissions (% of total fuel combustion) of World per year?
Offer a terse response. 20.81. What is the average CO2 emissions (% of total fuel combustion) of Dominican Republic per year?
Your answer should be compact. 33.63. What is the average CO2 emissions (% of total fuel combustion) in Senegal per year?
Ensure brevity in your answer.  31.84. In the year 1994, what is the difference between the CO2 emissions (% of total fuel combustion) in High income and CO2 emissions (% of total fuel combustion) in World?
Provide a succinct answer. 3.66. In the year 1994, what is the difference between the CO2 emissions (% of total fuel combustion) of High income and CO2 emissions (% of total fuel combustion) of Dominican Republic?
Keep it short and to the point. -5.67. In the year 1994, what is the difference between the CO2 emissions (% of total fuel combustion) of High income and CO2 emissions (% of total fuel combustion) of Senegal?
Offer a very short reply. -7.96. In the year 1994, what is the difference between the CO2 emissions (% of total fuel combustion) of World and CO2 emissions (% of total fuel combustion) of Dominican Republic?
Ensure brevity in your answer.  -9.32. In the year 1994, what is the difference between the CO2 emissions (% of total fuel combustion) of World and CO2 emissions (% of total fuel combustion) of Senegal?
Your answer should be very brief. -11.62. In the year 1994, what is the difference between the CO2 emissions (% of total fuel combustion) in Dominican Republic and CO2 emissions (% of total fuel combustion) in Senegal?
Your response must be concise. -2.29. In the year 1995, what is the difference between the CO2 emissions (% of total fuel combustion) in High income and CO2 emissions (% of total fuel combustion) in World?
Your answer should be compact. 3.76. In the year 1995, what is the difference between the CO2 emissions (% of total fuel combustion) in High income and CO2 emissions (% of total fuel combustion) in Senegal?
Keep it short and to the point. -7.55. In the year 1995, what is the difference between the CO2 emissions (% of total fuel combustion) in World and CO2 emissions (% of total fuel combustion) in Dominican Republic?
Provide a short and direct response. -10.86. In the year 1995, what is the difference between the CO2 emissions (% of total fuel combustion) in World and CO2 emissions (% of total fuel combustion) in Senegal?
Ensure brevity in your answer.  -11.31. In the year 1995, what is the difference between the CO2 emissions (% of total fuel combustion) of Dominican Republic and CO2 emissions (% of total fuel combustion) of Senegal?
Your answer should be compact. -0.45. In the year 1996, what is the difference between the CO2 emissions (% of total fuel combustion) in High income and CO2 emissions (% of total fuel combustion) in World?
Provide a short and direct response. 3.33. In the year 1996, what is the difference between the CO2 emissions (% of total fuel combustion) of High income and CO2 emissions (% of total fuel combustion) of Dominican Republic?
Offer a terse response. -8.22. In the year 1996, what is the difference between the CO2 emissions (% of total fuel combustion) of High income and CO2 emissions (% of total fuel combustion) of Senegal?
Make the answer very short. -8.49. In the year 1996, what is the difference between the CO2 emissions (% of total fuel combustion) in World and CO2 emissions (% of total fuel combustion) in Dominican Republic?
Offer a very short reply. -11.55. In the year 1996, what is the difference between the CO2 emissions (% of total fuel combustion) in World and CO2 emissions (% of total fuel combustion) in Senegal?
Offer a terse response. -11.82. In the year 1996, what is the difference between the CO2 emissions (% of total fuel combustion) of Dominican Republic and CO2 emissions (% of total fuel combustion) of Senegal?
Offer a very short reply. -0.27. In the year 1997, what is the difference between the CO2 emissions (% of total fuel combustion) in High income and CO2 emissions (% of total fuel combustion) in World?
Provide a short and direct response. 3.39. In the year 1997, what is the difference between the CO2 emissions (% of total fuel combustion) in High income and CO2 emissions (% of total fuel combustion) in Dominican Republic?
Provide a succinct answer. -8.34. In the year 1997, what is the difference between the CO2 emissions (% of total fuel combustion) of High income and CO2 emissions (% of total fuel combustion) of Senegal?
Offer a very short reply. -7.77. In the year 1997, what is the difference between the CO2 emissions (% of total fuel combustion) in World and CO2 emissions (% of total fuel combustion) in Dominican Republic?
Provide a short and direct response. -11.72. In the year 1997, what is the difference between the CO2 emissions (% of total fuel combustion) in World and CO2 emissions (% of total fuel combustion) in Senegal?
Ensure brevity in your answer.  -11.16. In the year 1997, what is the difference between the CO2 emissions (% of total fuel combustion) of Dominican Republic and CO2 emissions (% of total fuel combustion) of Senegal?
Your answer should be very brief. 0.56. In the year 1998, what is the difference between the CO2 emissions (% of total fuel combustion) in High income and CO2 emissions (% of total fuel combustion) in World?
Provide a short and direct response. 3.69. In the year 1998, what is the difference between the CO2 emissions (% of total fuel combustion) in High income and CO2 emissions (% of total fuel combustion) in Dominican Republic?
Offer a very short reply. -10.47. In the year 1998, what is the difference between the CO2 emissions (% of total fuel combustion) in High income and CO2 emissions (% of total fuel combustion) in Senegal?
Offer a very short reply. -7.05. In the year 1998, what is the difference between the CO2 emissions (% of total fuel combustion) of World and CO2 emissions (% of total fuel combustion) of Dominican Republic?
Provide a short and direct response. -14.16. In the year 1998, what is the difference between the CO2 emissions (% of total fuel combustion) in World and CO2 emissions (% of total fuel combustion) in Senegal?
Provide a short and direct response. -10.73. In the year 1998, what is the difference between the CO2 emissions (% of total fuel combustion) of Dominican Republic and CO2 emissions (% of total fuel combustion) of Senegal?
Your answer should be very brief. 3.43. In the year 1999, what is the difference between the CO2 emissions (% of total fuel combustion) in High income and CO2 emissions (% of total fuel combustion) in World?
Ensure brevity in your answer.  3.64. In the year 1999, what is the difference between the CO2 emissions (% of total fuel combustion) of High income and CO2 emissions (% of total fuel combustion) of Dominican Republic?
Keep it short and to the point. -12.63. In the year 1999, what is the difference between the CO2 emissions (% of total fuel combustion) of High income and CO2 emissions (% of total fuel combustion) of Senegal?
Offer a terse response. -5.69. In the year 1999, what is the difference between the CO2 emissions (% of total fuel combustion) in World and CO2 emissions (% of total fuel combustion) in Dominican Republic?
Provide a succinct answer. -16.27. In the year 1999, what is the difference between the CO2 emissions (% of total fuel combustion) in World and CO2 emissions (% of total fuel combustion) in Senegal?
Your answer should be very brief. -9.33. In the year 1999, what is the difference between the CO2 emissions (% of total fuel combustion) of Dominican Republic and CO2 emissions (% of total fuel combustion) of Senegal?
Offer a terse response. 6.94. In the year 2000, what is the difference between the CO2 emissions (% of total fuel combustion) of High income and CO2 emissions (% of total fuel combustion) of World?
Offer a very short reply. 3.31. In the year 2000, what is the difference between the CO2 emissions (% of total fuel combustion) of High income and CO2 emissions (% of total fuel combustion) of Dominican Republic?
Keep it short and to the point. -12.59. In the year 2000, what is the difference between the CO2 emissions (% of total fuel combustion) of High income and CO2 emissions (% of total fuel combustion) of Senegal?
Keep it short and to the point. -7.93. In the year 2000, what is the difference between the CO2 emissions (% of total fuel combustion) of World and CO2 emissions (% of total fuel combustion) of Dominican Republic?
Offer a terse response. -15.9. In the year 2000, what is the difference between the CO2 emissions (% of total fuel combustion) of World and CO2 emissions (% of total fuel combustion) of Senegal?
Provide a succinct answer. -11.25. In the year 2000, what is the difference between the CO2 emissions (% of total fuel combustion) in Dominican Republic and CO2 emissions (% of total fuel combustion) in Senegal?
Make the answer very short. 4.65. What is the ratio of the CO2 emissions (% of total fuel combustion) in Dominican Republic in 1994 to that in 1995?
Your answer should be very brief. 0.95. What is the ratio of the CO2 emissions (% of total fuel combustion) of Senegal in 1994 to that in 1995?
Provide a short and direct response. 1.01. What is the ratio of the CO2 emissions (% of total fuel combustion) in High income in 1994 to that in 1996?
Your response must be concise. 1. What is the ratio of the CO2 emissions (% of total fuel combustion) of World in 1994 to that in 1996?
Provide a short and direct response. 0.98. What is the ratio of the CO2 emissions (% of total fuel combustion) of Dominican Republic in 1994 to that in 1996?
Offer a very short reply. 0.92. What is the ratio of the CO2 emissions (% of total fuel combustion) in Senegal in 1994 to that in 1996?
Provide a succinct answer. 0.98. What is the ratio of the CO2 emissions (% of total fuel combustion) in World in 1994 to that in 1997?
Your answer should be compact. 0.98. What is the ratio of the CO2 emissions (% of total fuel combustion) in Dominican Republic in 1994 to that in 1997?
Offer a very short reply. 0.91. What is the ratio of the CO2 emissions (% of total fuel combustion) in Senegal in 1994 to that in 1997?
Provide a short and direct response. 1. What is the ratio of the CO2 emissions (% of total fuel combustion) of High income in 1994 to that in 1998?
Your response must be concise. 0.97. What is the ratio of the CO2 emissions (% of total fuel combustion) in Dominican Republic in 1994 to that in 1998?
Provide a short and direct response. 0.84. What is the ratio of the CO2 emissions (% of total fuel combustion) in High income in 1994 to that in 1999?
Keep it short and to the point. 0.95. What is the ratio of the CO2 emissions (% of total fuel combustion) in World in 1994 to that in 1999?
Ensure brevity in your answer.  0.94. What is the ratio of the CO2 emissions (% of total fuel combustion) in Dominican Republic in 1994 to that in 1999?
Provide a short and direct response. 0.78. What is the ratio of the CO2 emissions (% of total fuel combustion) in Senegal in 1994 to that in 1999?
Give a very brief answer. 1.04. What is the ratio of the CO2 emissions (% of total fuel combustion) of High income in 1994 to that in 2000?
Offer a terse response. 0.97. What is the ratio of the CO2 emissions (% of total fuel combustion) of World in 1994 to that in 2000?
Offer a very short reply. 0.95. What is the ratio of the CO2 emissions (% of total fuel combustion) of Dominican Republic in 1994 to that in 2000?
Offer a terse response. 0.8. What is the ratio of the CO2 emissions (% of total fuel combustion) in Senegal in 1994 to that in 2000?
Provide a succinct answer. 0.98. What is the ratio of the CO2 emissions (% of total fuel combustion) in World in 1995 to that in 1996?
Provide a short and direct response. 0.98. What is the ratio of the CO2 emissions (% of total fuel combustion) of Dominican Republic in 1995 to that in 1996?
Ensure brevity in your answer.  0.97. What is the ratio of the CO2 emissions (% of total fuel combustion) of Senegal in 1995 to that in 1996?
Give a very brief answer. 0.97. What is the ratio of the CO2 emissions (% of total fuel combustion) of World in 1995 to that in 1997?
Provide a succinct answer. 0.98. What is the ratio of the CO2 emissions (% of total fuel combustion) in Dominican Republic in 1995 to that in 1997?
Make the answer very short. 0.96. What is the ratio of the CO2 emissions (% of total fuel combustion) in Senegal in 1995 to that in 1997?
Your response must be concise. 0.99. What is the ratio of the CO2 emissions (% of total fuel combustion) in High income in 1995 to that in 1998?
Your answer should be very brief. 0.97. What is the ratio of the CO2 emissions (% of total fuel combustion) of Dominican Republic in 1995 to that in 1998?
Provide a short and direct response. 0.88. What is the ratio of the CO2 emissions (% of total fuel combustion) of High income in 1995 to that in 1999?
Provide a short and direct response. 0.96. What is the ratio of the CO2 emissions (% of total fuel combustion) in World in 1995 to that in 1999?
Offer a very short reply. 0.94. What is the ratio of the CO2 emissions (% of total fuel combustion) in Dominican Republic in 1995 to that in 1999?
Your answer should be compact. 0.82. What is the ratio of the CO2 emissions (% of total fuel combustion) in Senegal in 1995 to that in 1999?
Give a very brief answer. 1.03. What is the ratio of the CO2 emissions (% of total fuel combustion) in High income in 1995 to that in 2000?
Keep it short and to the point. 0.97. What is the ratio of the CO2 emissions (% of total fuel combustion) in World in 1995 to that in 2000?
Make the answer very short. 0.95. What is the ratio of the CO2 emissions (% of total fuel combustion) of Dominican Republic in 1995 to that in 2000?
Give a very brief answer. 0.84. What is the ratio of the CO2 emissions (% of total fuel combustion) in Senegal in 1995 to that in 2000?
Keep it short and to the point. 0.97. What is the ratio of the CO2 emissions (% of total fuel combustion) of High income in 1996 to that in 1997?
Keep it short and to the point. 1. What is the ratio of the CO2 emissions (% of total fuel combustion) of World in 1996 to that in 1997?
Your answer should be compact. 1. What is the ratio of the CO2 emissions (% of total fuel combustion) of Dominican Republic in 1996 to that in 1997?
Offer a terse response. 0.99. What is the ratio of the CO2 emissions (% of total fuel combustion) in Senegal in 1996 to that in 1997?
Offer a terse response. 1.02. What is the ratio of the CO2 emissions (% of total fuel combustion) in High income in 1996 to that in 1998?
Offer a terse response. 0.97. What is the ratio of the CO2 emissions (% of total fuel combustion) in World in 1996 to that in 1998?
Ensure brevity in your answer.  0.98. What is the ratio of the CO2 emissions (% of total fuel combustion) of Dominican Republic in 1996 to that in 1998?
Your answer should be very brief. 0.91. What is the ratio of the CO2 emissions (% of total fuel combustion) in Senegal in 1996 to that in 1998?
Offer a very short reply. 1.02. What is the ratio of the CO2 emissions (% of total fuel combustion) in High income in 1996 to that in 1999?
Keep it short and to the point. 0.95. What is the ratio of the CO2 emissions (% of total fuel combustion) in World in 1996 to that in 1999?
Keep it short and to the point. 0.96. What is the ratio of the CO2 emissions (% of total fuel combustion) of Dominican Republic in 1996 to that in 1999?
Your response must be concise. 0.85. What is the ratio of the CO2 emissions (% of total fuel combustion) of Senegal in 1996 to that in 1999?
Your answer should be compact. 1.05. What is the ratio of the CO2 emissions (% of total fuel combustion) of High income in 1996 to that in 2000?
Offer a very short reply. 0.97. What is the ratio of the CO2 emissions (% of total fuel combustion) of World in 1996 to that in 2000?
Give a very brief answer. 0.97. What is the ratio of the CO2 emissions (% of total fuel combustion) in Dominican Republic in 1996 to that in 2000?
Your response must be concise. 0.86. What is the ratio of the CO2 emissions (% of total fuel combustion) of High income in 1997 to that in 1998?
Provide a succinct answer. 0.97. What is the ratio of the CO2 emissions (% of total fuel combustion) of World in 1997 to that in 1998?
Offer a terse response. 0.98. What is the ratio of the CO2 emissions (% of total fuel combustion) of Dominican Republic in 1997 to that in 1998?
Make the answer very short. 0.92. What is the ratio of the CO2 emissions (% of total fuel combustion) of High income in 1997 to that in 1999?
Make the answer very short. 0.96. What is the ratio of the CO2 emissions (% of total fuel combustion) in World in 1997 to that in 1999?
Provide a short and direct response. 0.96. What is the ratio of the CO2 emissions (% of total fuel combustion) in Dominican Republic in 1997 to that in 1999?
Provide a succinct answer. 0.86. What is the ratio of the CO2 emissions (% of total fuel combustion) in Senegal in 1997 to that in 1999?
Offer a terse response. 1.03. What is the ratio of the CO2 emissions (% of total fuel combustion) of High income in 1997 to that in 2000?
Your response must be concise. 0.98. What is the ratio of the CO2 emissions (% of total fuel combustion) in World in 1997 to that in 2000?
Keep it short and to the point. 0.97. What is the ratio of the CO2 emissions (% of total fuel combustion) of Dominican Republic in 1997 to that in 2000?
Your answer should be very brief. 0.87. What is the ratio of the CO2 emissions (% of total fuel combustion) in Senegal in 1997 to that in 2000?
Ensure brevity in your answer.  0.98. What is the ratio of the CO2 emissions (% of total fuel combustion) in High income in 1998 to that in 1999?
Make the answer very short. 0.98. What is the ratio of the CO2 emissions (% of total fuel combustion) of World in 1998 to that in 1999?
Ensure brevity in your answer.  0.98. What is the ratio of the CO2 emissions (% of total fuel combustion) of Dominican Republic in 1998 to that in 1999?
Keep it short and to the point. 0.93. What is the ratio of the CO2 emissions (% of total fuel combustion) in Senegal in 1998 to that in 1999?
Make the answer very short. 1.03. What is the ratio of the CO2 emissions (% of total fuel combustion) of High income in 1998 to that in 2000?
Offer a very short reply. 1. What is the ratio of the CO2 emissions (% of total fuel combustion) in World in 1998 to that in 2000?
Offer a very short reply. 0.99. What is the ratio of the CO2 emissions (% of total fuel combustion) of Dominican Republic in 1998 to that in 2000?
Keep it short and to the point. 0.94. What is the ratio of the CO2 emissions (% of total fuel combustion) in Senegal in 1998 to that in 2000?
Your response must be concise. 0.97. What is the ratio of the CO2 emissions (% of total fuel combustion) of High income in 1999 to that in 2000?
Keep it short and to the point. 1.02. What is the ratio of the CO2 emissions (% of total fuel combustion) of World in 1999 to that in 2000?
Provide a short and direct response. 1.01. What is the ratio of the CO2 emissions (% of total fuel combustion) of Dominican Republic in 1999 to that in 2000?
Your response must be concise. 1.01. What is the ratio of the CO2 emissions (% of total fuel combustion) in Senegal in 1999 to that in 2000?
Your response must be concise. 0.94. What is the difference between the highest and the second highest CO2 emissions (% of total fuel combustion) of High income?
Your answer should be compact. 0.39. What is the difference between the highest and the second highest CO2 emissions (% of total fuel combustion) of World?
Make the answer very short. 0.13. What is the difference between the highest and the second highest CO2 emissions (% of total fuel combustion) in Dominican Republic?
Provide a short and direct response. 0.5. What is the difference between the highest and the second highest CO2 emissions (% of total fuel combustion) of Senegal?
Offer a terse response. 0.15. What is the difference between the highest and the lowest CO2 emissions (% of total fuel combustion) of High income?
Your response must be concise. 1.17. What is the difference between the highest and the lowest CO2 emissions (% of total fuel combustion) of World?
Offer a very short reply. 1.19. What is the difference between the highest and the lowest CO2 emissions (% of total fuel combustion) of Dominican Republic?
Keep it short and to the point. 8.13. What is the difference between the highest and the lowest CO2 emissions (% of total fuel combustion) in Senegal?
Give a very brief answer. 1.79. 